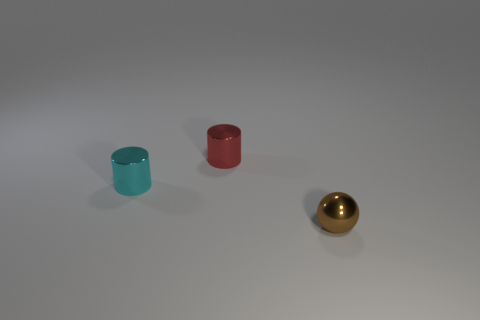Is there anything else that has the same shape as the brown metal thing?
Offer a terse response. No. Is the number of tiny metal things behind the red object the same as the number of tiny rubber cubes?
Provide a short and direct response. Yes. Is the shape of the shiny object that is left of the red thing the same as the tiny thing that is behind the tiny cyan metallic cylinder?
Provide a short and direct response. Yes. There is a object that is in front of the tiny red cylinder and to the right of the tiny cyan shiny object; what color is it?
Provide a succinct answer. Brown. Is there a red object that is behind the cylinder in front of the thing behind the cyan cylinder?
Provide a succinct answer. Yes. How many things are tiny cyan things or big brown matte blocks?
Give a very brief answer. 1. Do the tiny sphere and the small object that is to the left of the tiny red metallic object have the same material?
Make the answer very short. Yes. What number of objects are tiny red cylinders that are behind the small cyan cylinder or small things in front of the small red thing?
Give a very brief answer. 3. There is a small object that is behind the small brown sphere and right of the tiny cyan metallic cylinder; what is its shape?
Provide a succinct answer. Cylinder. There is a small cylinder behind the cyan metal cylinder; what number of red shiny cylinders are to the right of it?
Provide a short and direct response. 0. 